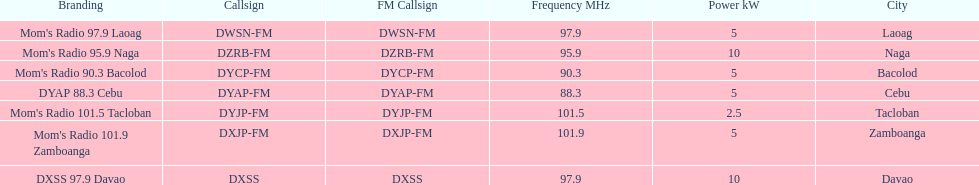What is the total number of stations with frequencies above 100 mhz? 2. 